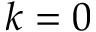Convert formula to latex. <formula><loc_0><loc_0><loc_500><loc_500>k = 0</formula> 